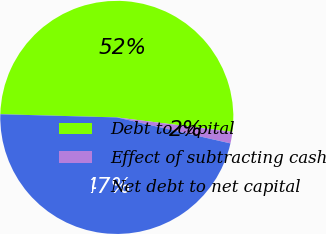Convert chart to OTSL. <chart><loc_0><loc_0><loc_500><loc_500><pie_chart><fcel>Debt to capital<fcel>Effect of subtracting cash<fcel>Net debt to net capital<nl><fcel>51.54%<fcel>1.6%<fcel>46.85%<nl></chart> 